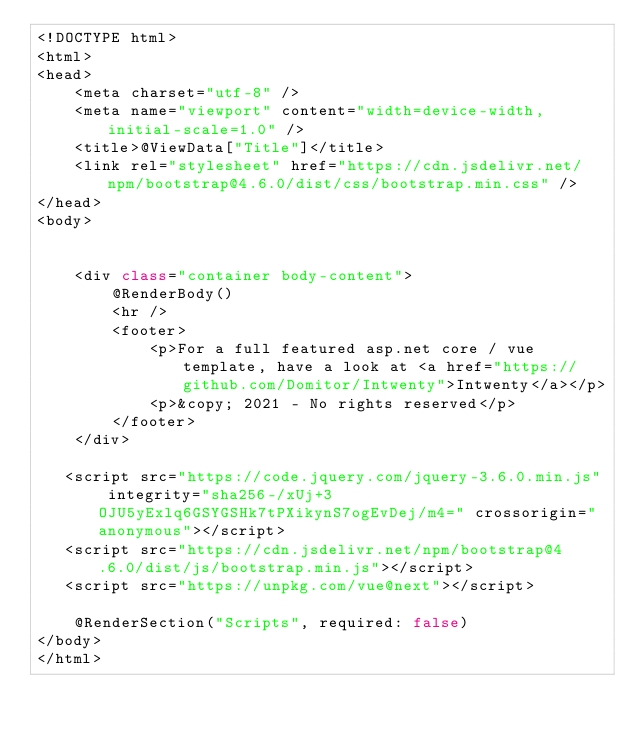Convert code to text. <code><loc_0><loc_0><loc_500><loc_500><_C#_><!DOCTYPE html>
<html>
<head>
    <meta charset="utf-8" />
    <meta name="viewport" content="width=device-width, initial-scale=1.0" />
    <title>@ViewData["Title"]</title>
    <link rel="stylesheet" href="https://cdn.jsdelivr.net/npm/bootstrap@4.6.0/dist/css/bootstrap.min.css" />
</head>
<body>
  

    <div class="container body-content">
        @RenderBody()
        <hr />
        <footer>
            <p>For a full featured asp.net core / vue template, have a look at <a href="https://github.com/Domitor/Intwenty">Intwenty</a></p>
            <p>&copy; 2021 - No rights reserved</p>
        </footer>
    </div>

   <script src="https://code.jquery.com/jquery-3.6.0.min.js" integrity="sha256-/xUj+3OJU5yExlq6GSYGSHk7tPXikynS7ogEvDej/m4=" crossorigin="anonymous"></script>
   <script src="https://cdn.jsdelivr.net/npm/bootstrap@4.6.0/dist/js/bootstrap.min.js"></script>
   <script src="https://unpkg.com/vue@next"></script>

    @RenderSection("Scripts", required: false)
</body>
</html></code> 